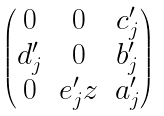Convert formula to latex. <formula><loc_0><loc_0><loc_500><loc_500>\begin{pmatrix} 0 & 0 & c ^ { \prime } _ { j } \\ d ^ { \prime } _ { j } & 0 & b ^ { \prime } _ { j } \\ 0 & e ^ { \prime } _ { j } z & a ^ { \prime } _ { j } \end{pmatrix}</formula> 